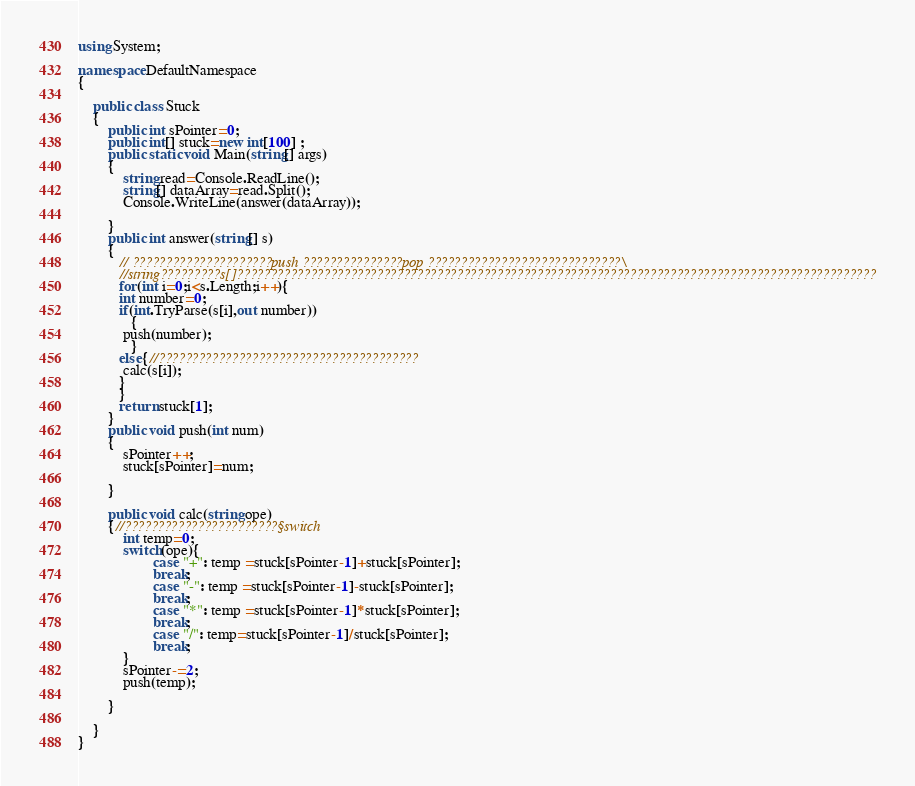<code> <loc_0><loc_0><loc_500><loc_500><_C#_>using System;

namespace DefaultNamespace
{
	
	public class Stuck
	{
		public int sPointer=0;
		public int[] stuck=new int[100] ;
		public static void Main(string[] args)
		{
			string read=Console.ReadLine();
			string[] dataArray=read.Split();
			Console.WriteLine(answer(dataArray));
			
		}
		public int answer(string[] s)
		{
		   // ?????????????????????push ???????????????pop ?????????????????????????????\
		   //string?????????s[]????????????????????????????????????????????????????????????????????????????????????????????????
		   for(int i=0;i<s.Length;i++){
		   int number=0;
		   if(int.TryParse(s[i],out number))
		      {
		   	push(number);
		      }
		   else{//???????????????????????????????????????
		   	calc(s[i]);
		   }
		   }
		   return stuck[1];
		}
		public void push(int num)
		{
			sPointer++;
			stuck[sPointer]=num;
			
		}
		
		public void calc(string ope)
		{//???????????????????????§switch
			int temp=0;
			switch(ope){
					case "+": temp =stuck[sPointer-1]+stuck[sPointer];
					break;
					case "-": temp =stuck[sPointer-1]-stuck[sPointer];
					break;
					case "*": temp =stuck[sPointer-1]*stuck[sPointer];
					break;
					case "/": temp=stuck[sPointer-1]/stuck[sPointer];
					break;
			}
			sPointer-=2;
			push(temp);
			
		}
		
	}
}</code> 